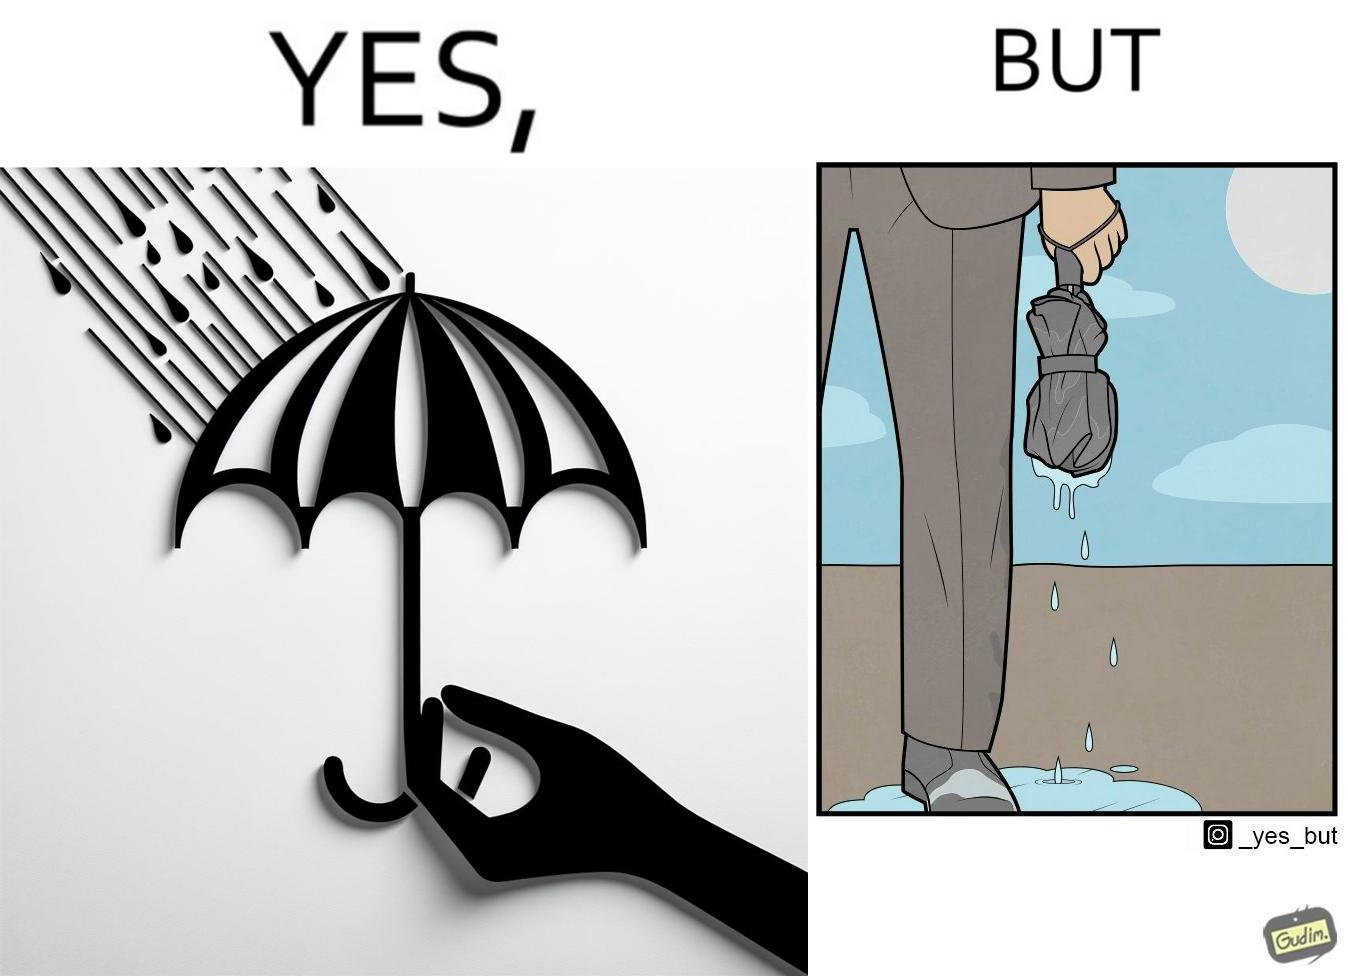Why is this image considered satirical? The image is funny because while the umbrella helps a person avoid getting wet from rain, when the rain stops and the umbrella is folded, the wet umbrella iteself drips water on the person holding it. 